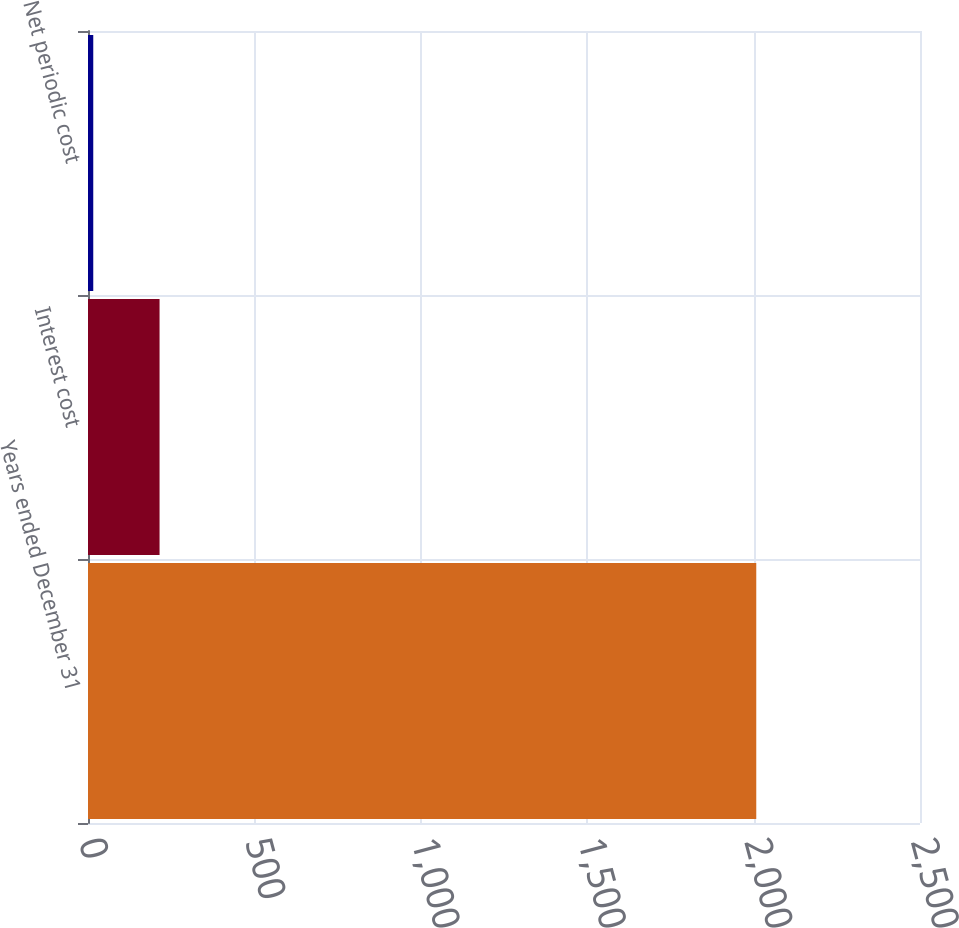<chart> <loc_0><loc_0><loc_500><loc_500><bar_chart><fcel>Years ended December 31<fcel>Interest cost<fcel>Net periodic cost<nl><fcel>2008<fcel>215.02<fcel>15.8<nl></chart> 